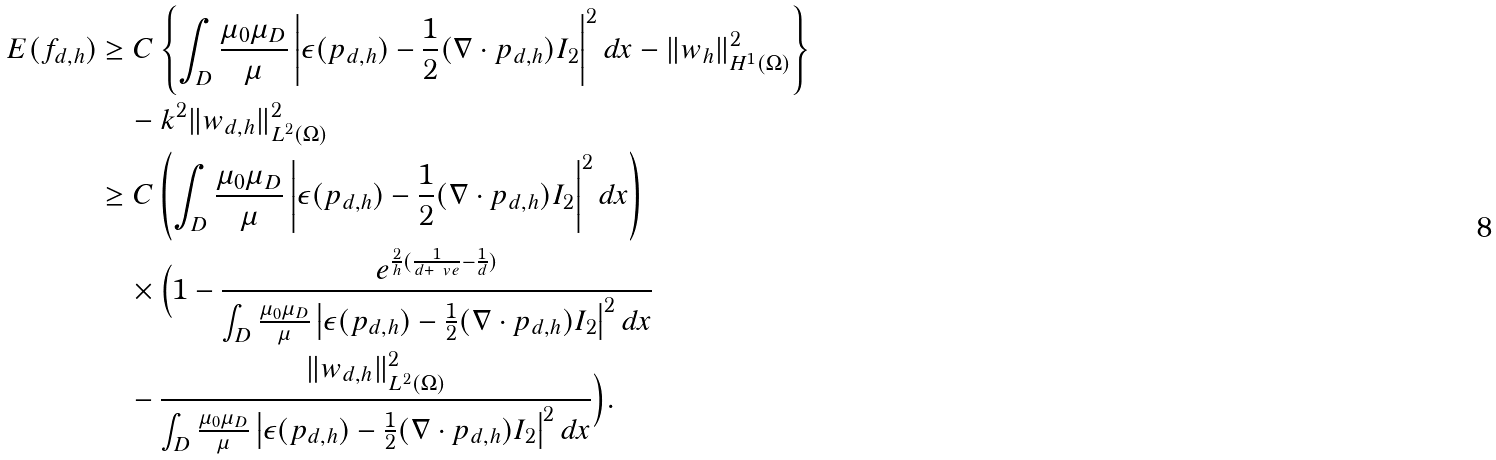Convert formula to latex. <formula><loc_0><loc_0><loc_500><loc_500>E ( f _ { d , h } ) & \geq C \left \{ \int _ { D } \frac { \mu _ { 0 } \mu _ { D } } { \mu } \left | \epsilon ( p _ { d , h } ) - \frac { 1 } { 2 } ( \nabla \cdot p _ { d , h } ) I _ { 2 } \right | ^ { 2 } d x - \| w _ { h } \| ^ { 2 } _ { H ^ { 1 } ( \Omega ) } \right \} \\ & \quad - k ^ { 2 } \| w _ { d , h } \| ^ { 2 } _ { L ^ { 2 } ( \Omega ) } \\ & \geq C \left ( \int _ { D } \frac { \mu _ { 0 } \mu _ { D } } { \mu } \left | \epsilon ( p _ { d , h } ) - \frac { 1 } { 2 } ( \nabla \cdot p _ { d , h } ) I _ { 2 } \right | ^ { 2 } d x \right ) \\ & \quad \times \Big { ( } 1 - \frac { e ^ { \frac { 2 } { h } ( \frac { 1 } { d + \ v e } - \frac { 1 } { d } ) } } { \int _ { D } \frac { \mu _ { 0 } \mu _ { D } } { \mu } \left | \epsilon ( p _ { d , h } ) - \frac { 1 } { 2 } ( \nabla \cdot p _ { d , h } ) I _ { 2 } \right | ^ { 2 } d x } \\ & \quad - \frac { \| w _ { d , h } \| ^ { 2 } _ { L ^ { 2 } ( \Omega ) } } { \int _ { D } \frac { \mu _ { 0 } \mu _ { D } } { \mu } \left | \epsilon ( p _ { d , h } ) - \frac { 1 } { 2 } ( \nabla \cdot p _ { d , h } ) I _ { 2 } \right | ^ { 2 } d x } \Big { ) } .</formula> 